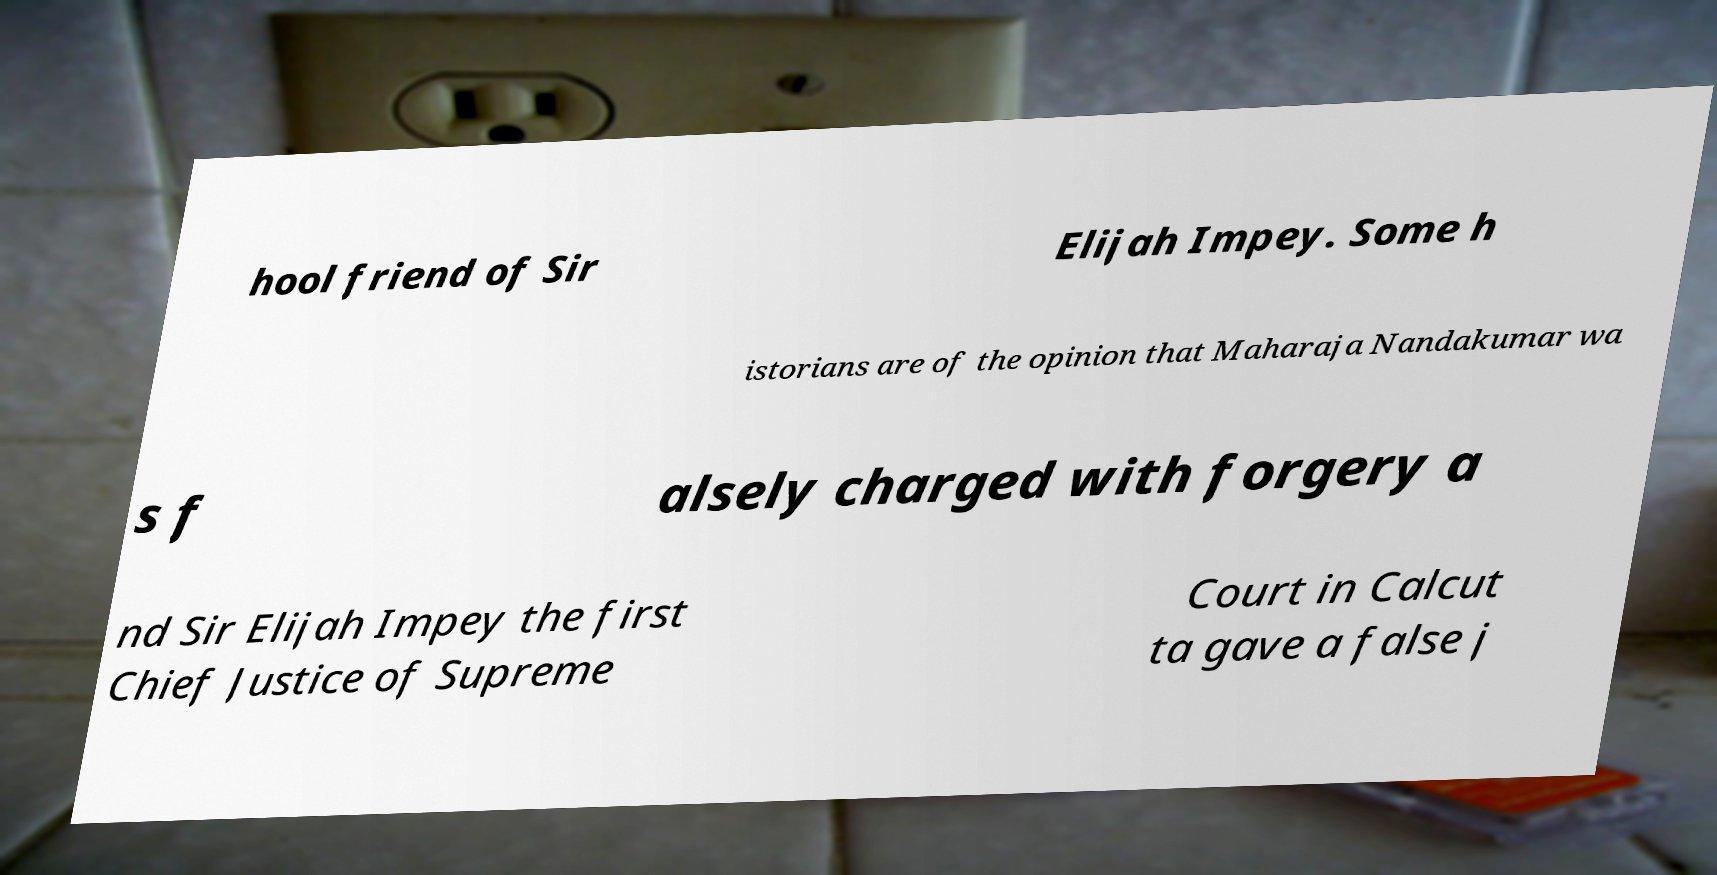For documentation purposes, I need the text within this image transcribed. Could you provide that? hool friend of Sir Elijah Impey. Some h istorians are of the opinion that Maharaja Nandakumar wa s f alsely charged with forgery a nd Sir Elijah Impey the first Chief Justice of Supreme Court in Calcut ta gave a false j 